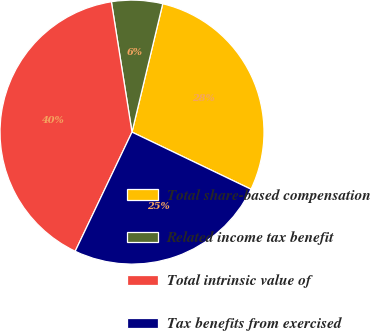<chart> <loc_0><loc_0><loc_500><loc_500><pie_chart><fcel>Total share-based compensation<fcel>Related income tax benefit<fcel>Total intrinsic value of<fcel>Tax benefits from exercised<nl><fcel>28.38%<fcel>6.24%<fcel>40.42%<fcel>24.96%<nl></chart> 